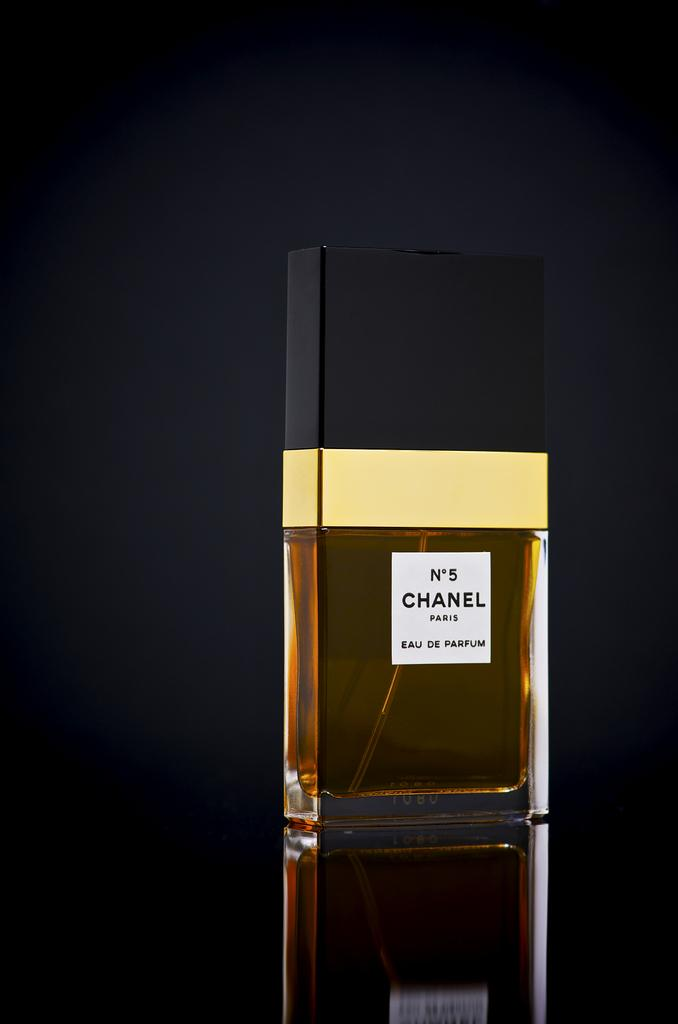Provide a one-sentence caption for the provided image. Chanel N.5 is expensive yet popular perfume that many people enjoy. 